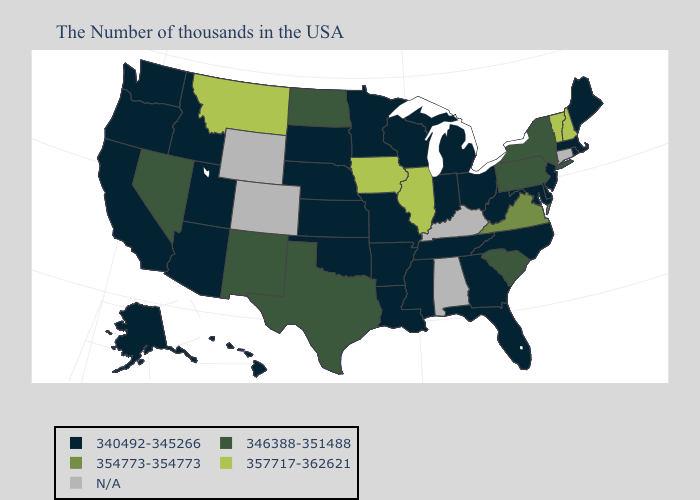What is the value of Missouri?
Short answer required. 340492-345266. What is the lowest value in the USA?
Short answer required. 340492-345266. What is the lowest value in the Northeast?
Short answer required. 340492-345266. What is the value of Colorado?
Quick response, please. N/A. What is the highest value in the Northeast ?
Write a very short answer. 357717-362621. What is the highest value in the USA?
Short answer required. 357717-362621. What is the lowest value in states that border Oklahoma?
Write a very short answer. 340492-345266. What is the lowest value in the Northeast?
Answer briefly. 340492-345266. What is the value of Idaho?
Give a very brief answer. 340492-345266. What is the value of Mississippi?
Answer briefly. 340492-345266. What is the value of Massachusetts?
Quick response, please. 340492-345266. Does Virginia have the lowest value in the South?
Give a very brief answer. No. What is the highest value in states that border Washington?
Keep it brief. 340492-345266. What is the lowest value in the USA?
Short answer required. 340492-345266. 